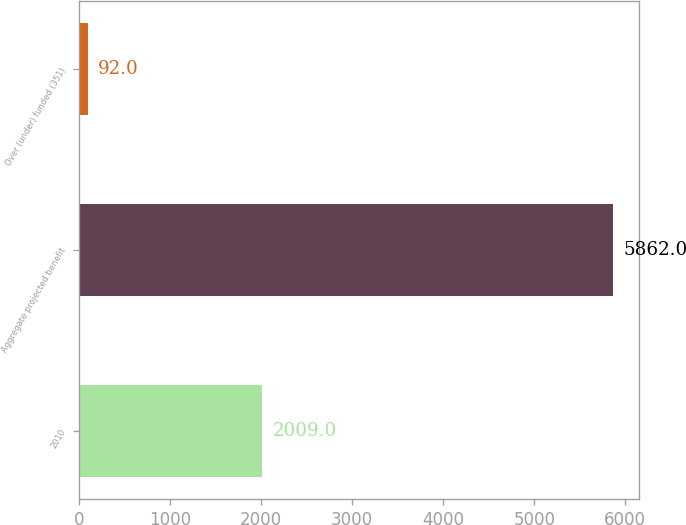Convert chart to OTSL. <chart><loc_0><loc_0><loc_500><loc_500><bar_chart><fcel>2010<fcel>Aggregate projected benefit<fcel>Over (under) funded (351)<nl><fcel>2009<fcel>5862<fcel>92<nl></chart> 